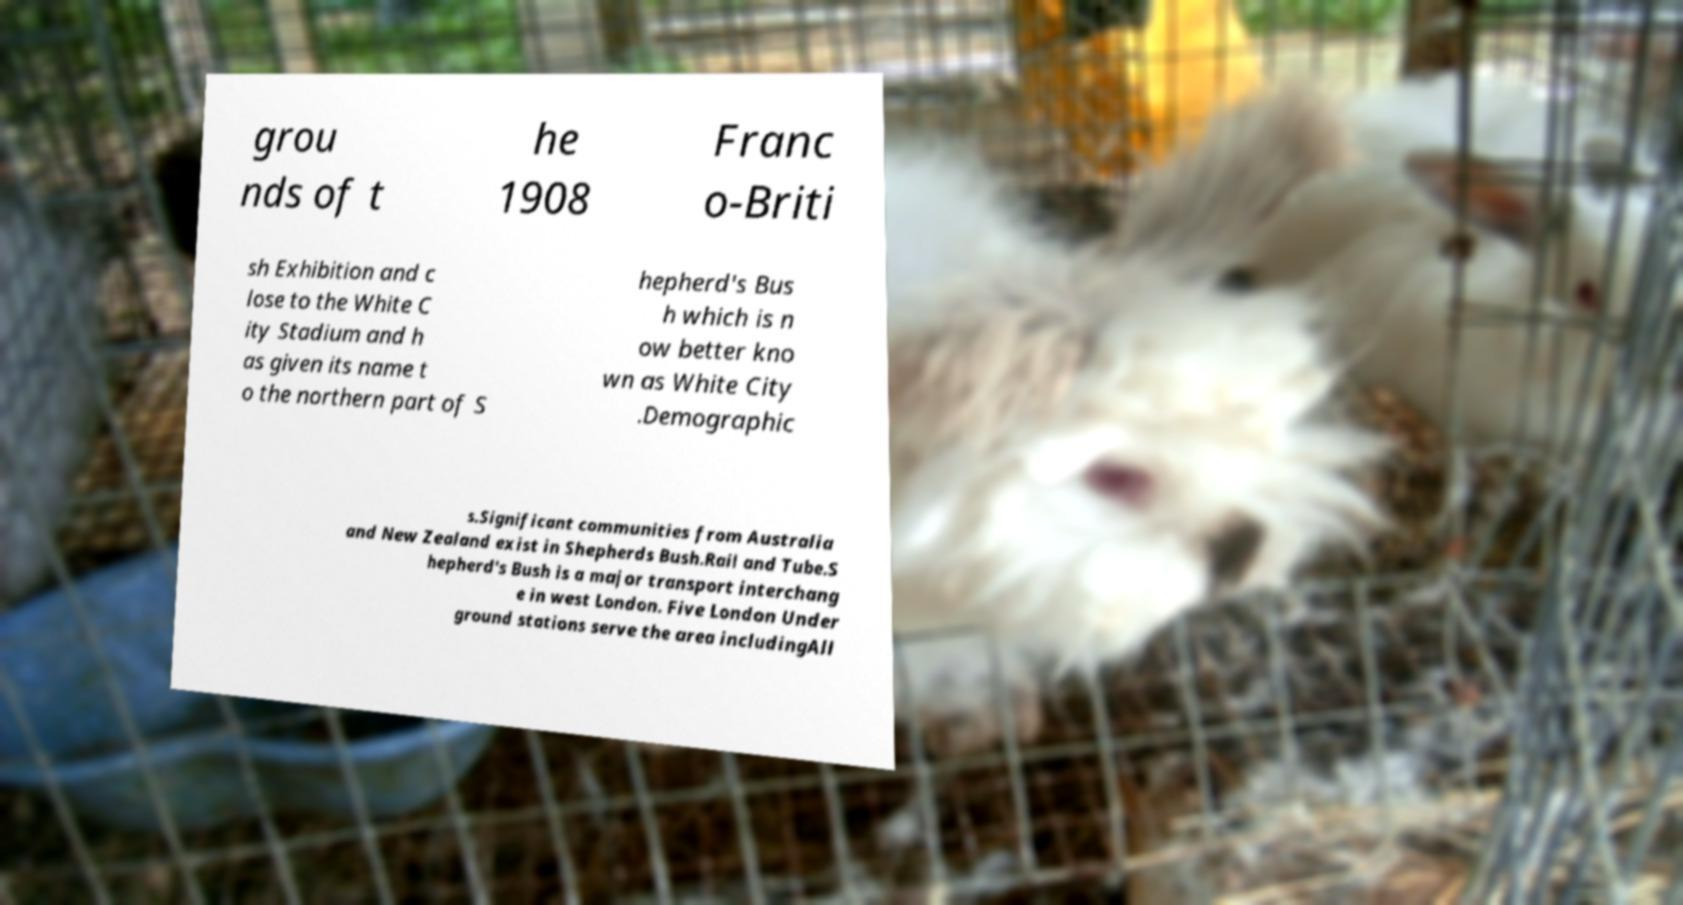Could you extract and type out the text from this image? grou nds of t he 1908 Franc o-Briti sh Exhibition and c lose to the White C ity Stadium and h as given its name t o the northern part of S hepherd's Bus h which is n ow better kno wn as White City .Demographic s.Significant communities from Australia and New Zealand exist in Shepherds Bush.Rail and Tube.S hepherd's Bush is a major transport interchang e in west London. Five London Under ground stations serve the area includingAll 